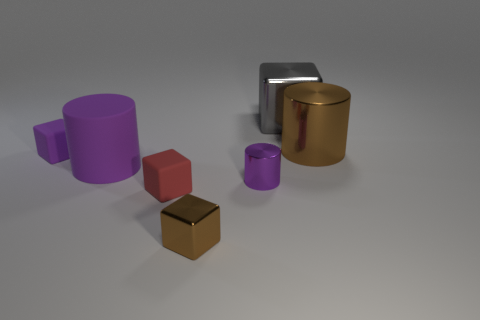Subtract 1 blocks. How many blocks are left? 3 Add 3 large rubber things. How many objects exist? 10 Subtract all cylinders. How many objects are left? 4 Add 4 tiny objects. How many tiny objects exist? 8 Subtract 0 yellow cubes. How many objects are left? 7 Subtract all small red blocks. Subtract all purple things. How many objects are left? 3 Add 3 tiny purple blocks. How many tiny purple blocks are left? 4 